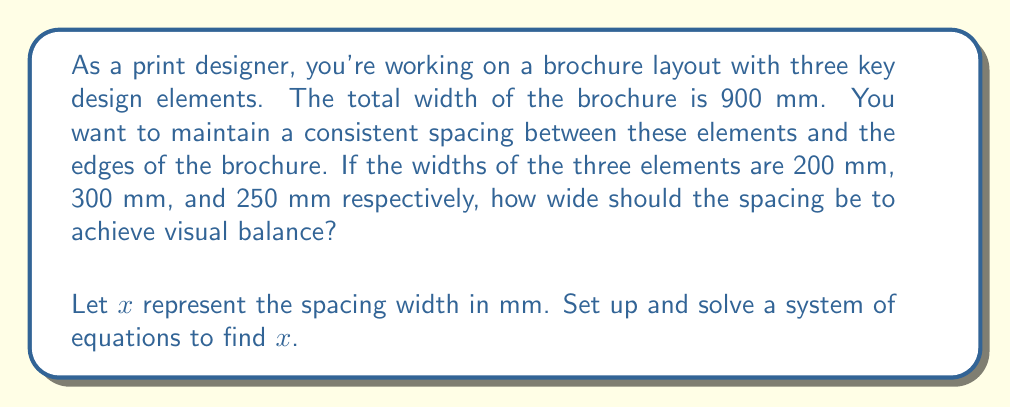Provide a solution to this math problem. To solve this problem, we need to set up an equation based on the given information:

1. The total width of the brochure is 900 mm.
2. There are three design elements with widths 200 mm, 300 mm, and 250 mm.
3. We need to find the consistent spacing $x$ between elements and edges.

Let's set up the equation:

$$ 4x + 200 + 300 + 250 = 900 $$

Here's why:
- We have 4 spaces: one on each edge and two between the elements (4x)
- We add the widths of the three elements (200 + 300 + 250)
- The total should equal the brochure width (900)

Now, let's solve the equation:

$$ 4x + 750 = 900 $$
$$ 4x = 900 - 750 $$
$$ 4x = 150 $$
$$ x = \frac{150}{4} = 37.5 $$

Therefore, the ideal spacing between design elements and edges should be 37.5 mm.

To verify:
$$ 37.5 + 200 + 37.5 + 300 + 37.5 + 250 + 37.5 = 900 $$

This confirms that our solution achieves the desired layout within the given brochure width.
Answer: $x = 37.5$ mm 